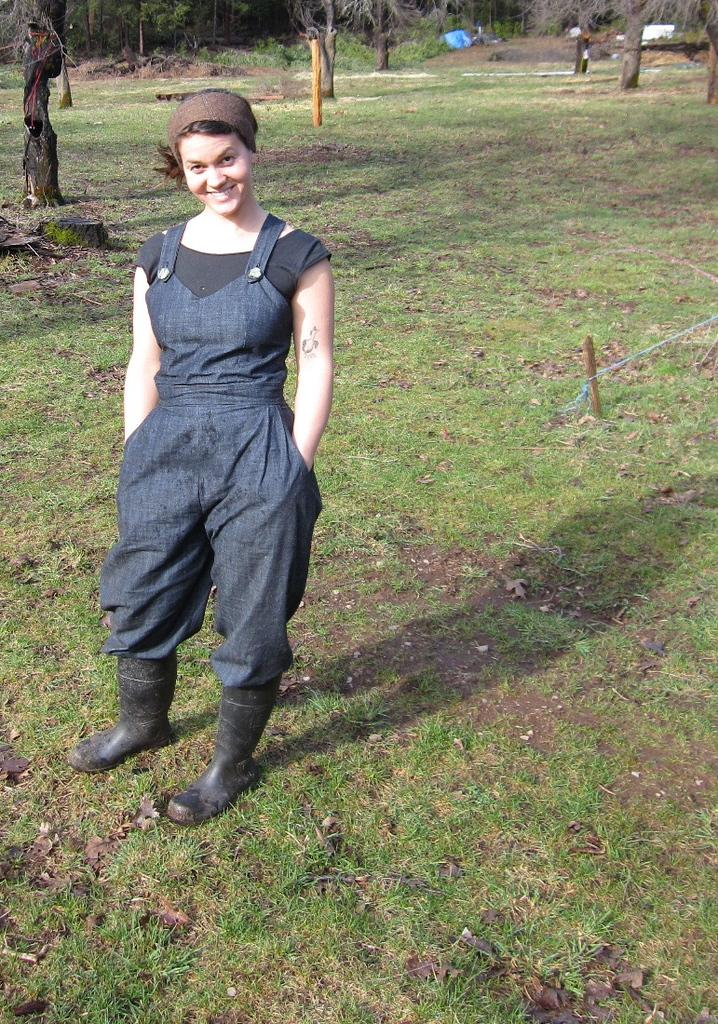What is the woman in the image doing? The woman is standing and smiling in the image. What is the woman wearing on her head? The woman is wearing a headband. What type of clothing is the woman wearing? The woman is wearing a jumpsuit and a T-shirt. What type of footwear is the woman wearing? The woman is wearing shoes. What type of natural environment is visible in the image? There is grass visible in the image, and tree trunks and trees are present in the background. Can you tell me how many kitties are playing on the coast in the image? There are no kitties or coast visible in the image; it features a woman standing and smiling in a natural environment with trees and grass. What is the woman learning in the image? There is no indication in the image that the woman is learning anything. 